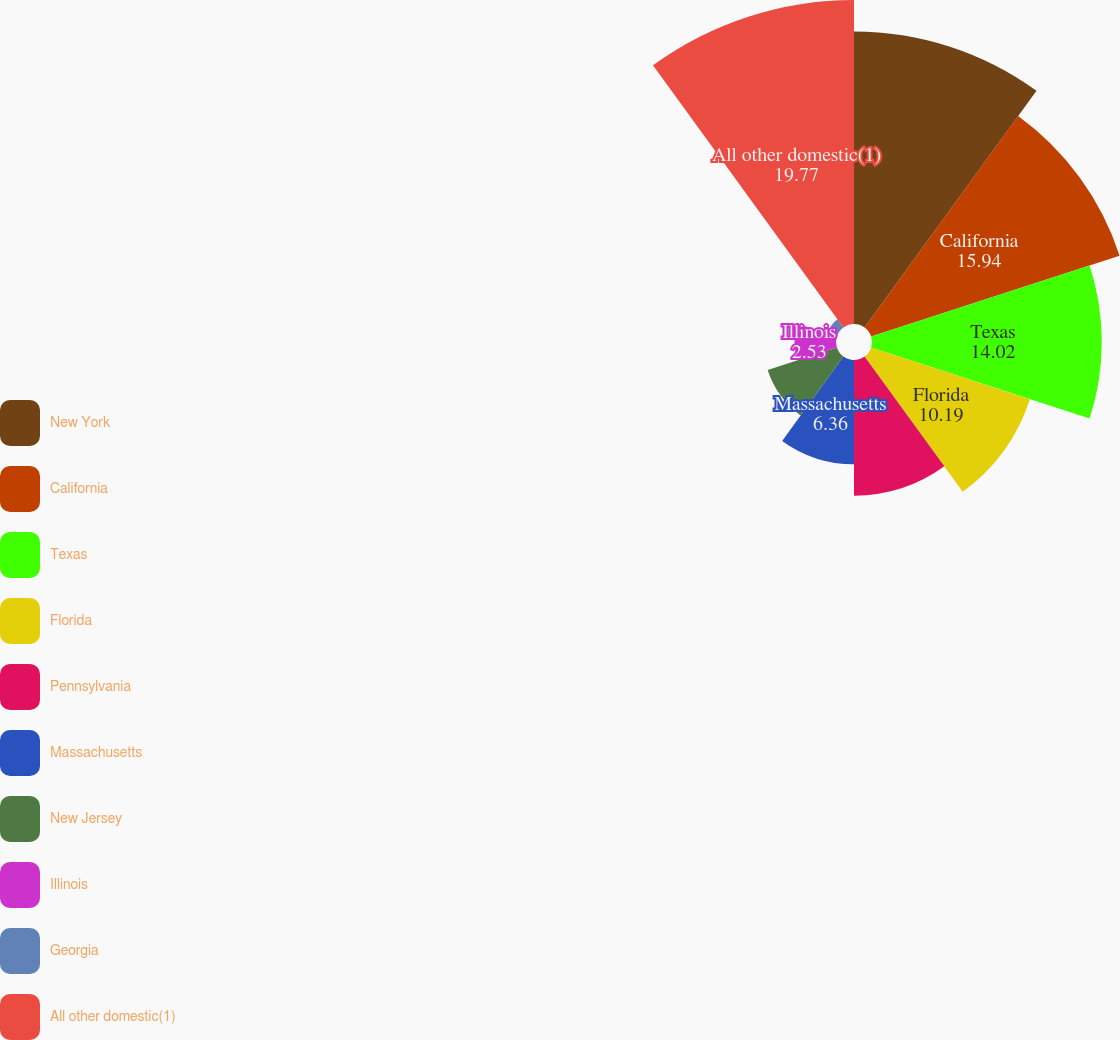Convert chart to OTSL. <chart><loc_0><loc_0><loc_500><loc_500><pie_chart><fcel>New York<fcel>California<fcel>Texas<fcel>Florida<fcel>Pennsylvania<fcel>Massachusetts<fcel>New Jersey<fcel>Illinois<fcel>Georgia<fcel>All other domestic(1)<nl><fcel>17.85%<fcel>15.94%<fcel>14.02%<fcel>10.19%<fcel>8.28%<fcel>6.36%<fcel>4.44%<fcel>2.53%<fcel>0.61%<fcel>19.77%<nl></chart> 